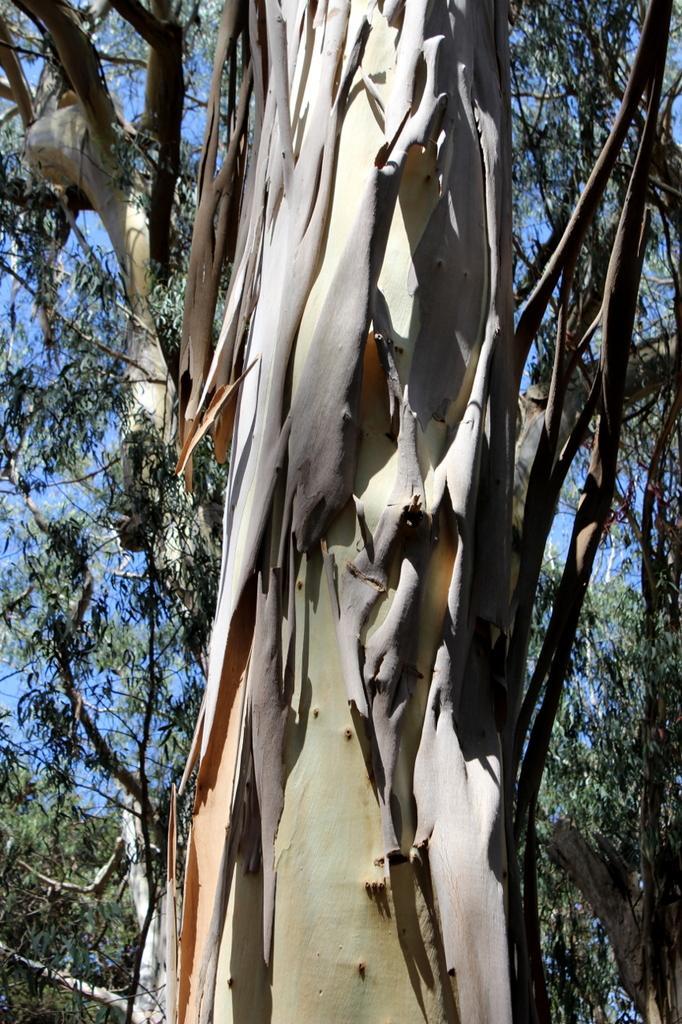Can you describe this image briefly? This picture is taken from the outside of the city. In this image, in the middle, we can see a tree. In the background, we can see some trees. In the background, we can also see a sky. 